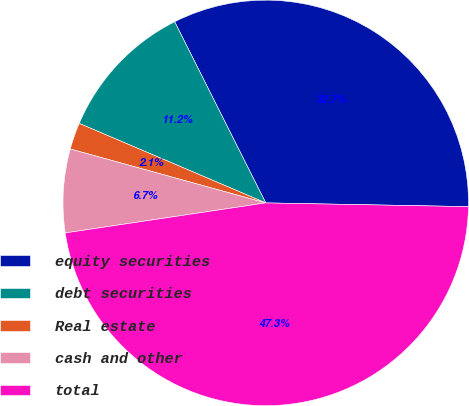<chart> <loc_0><loc_0><loc_500><loc_500><pie_chart><fcel>equity securities<fcel>debt securities<fcel>Real estate<fcel>cash and other<fcel>total<nl><fcel>32.71%<fcel>11.17%<fcel>2.13%<fcel>6.65%<fcel>47.34%<nl></chart> 